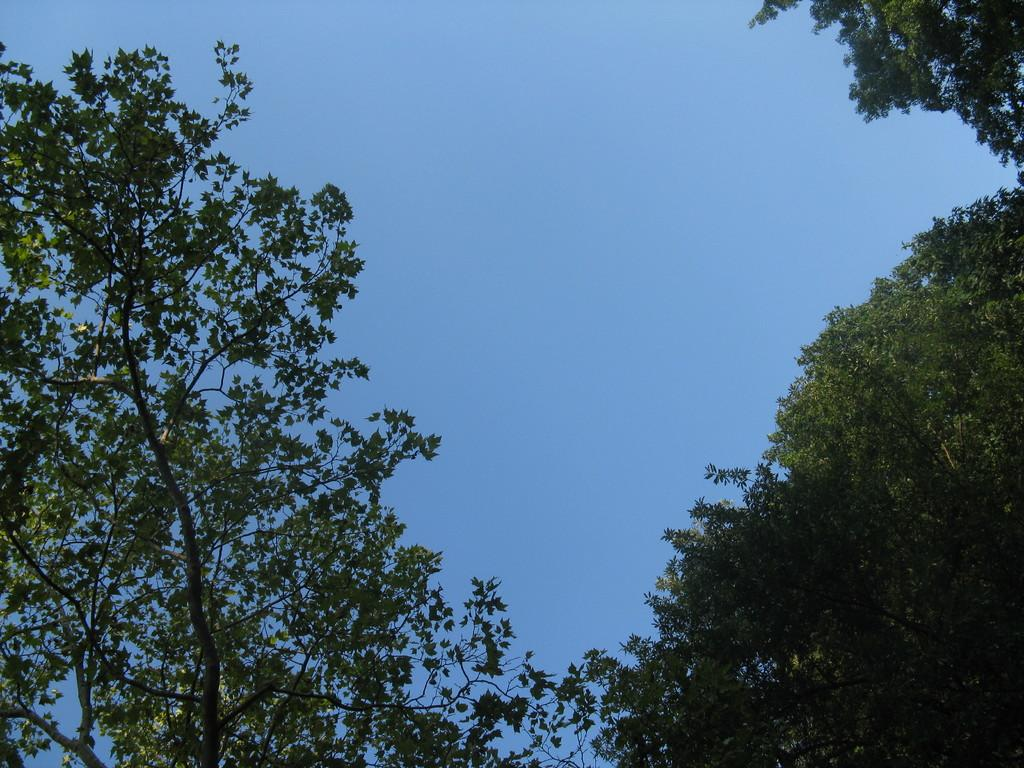What type of vegetation can be seen in the image? There are trees in the image. What is visible behind the trees in the image? The sky is visible behind the trees. Reasoning: Let's think step by identifying the main subjects and objects in the image based on the provided facts. We then formulate questions that focus on the location and characteristics of these subjects and objects, ensuring that each question can be answered definitively with the information given. We avoid yes/no questions and ensure that the language is simple and clear. Absurd Question/Answer: What type of jam is being spread on the army's uniforms in the image? There is no jam or army present in the image; it only features trees and the sky. How much cream is visible on the leaves of the trees in the image? There is no cream present on the trees in the image; it only features trees and the sky. What type of jam is being spread on the army's uniforms in the image? There is no jam or army present in the image; it only features trees and the sky. How much cream is visible on the leaves of the trees in the image? There is no cream present on the trees in the image; it only features trees and the sky. 